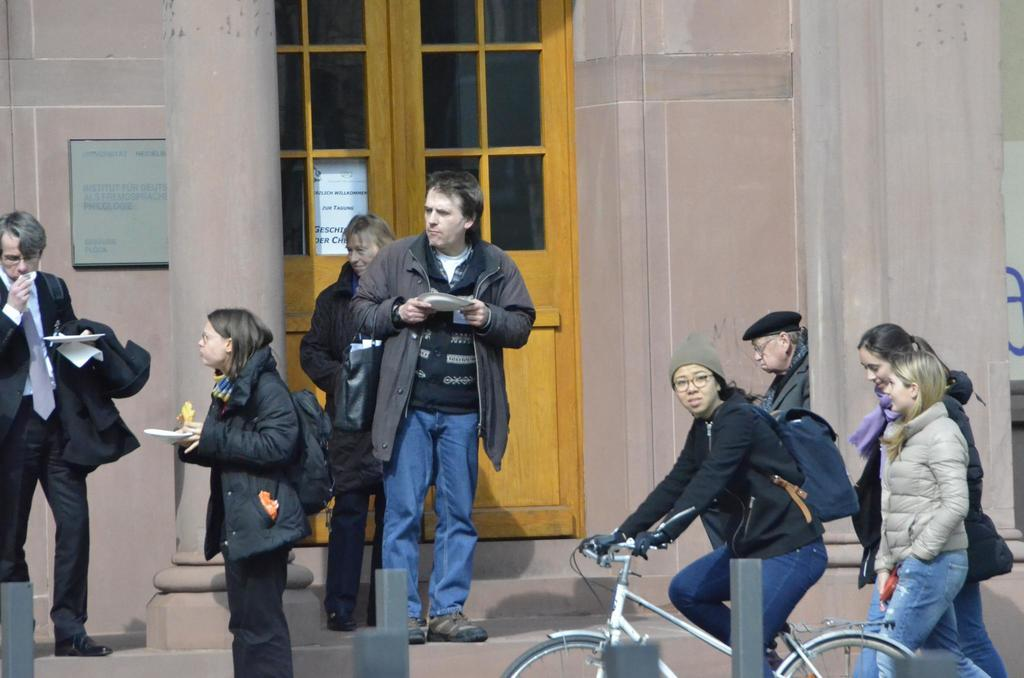What is the woman in the image doing? The woman is riding a cycle in the image. What can be seen in the background of the image? There is a wall, a door, a banner, and steps in the background of the image. Are there any people visible in the image? Yes, there are people standing on the steps in the background of the image. What type of bat is flying around the woman while she rides the cycle? There is no bat present in the image; the woman is riding a cycle without any animals around her. 